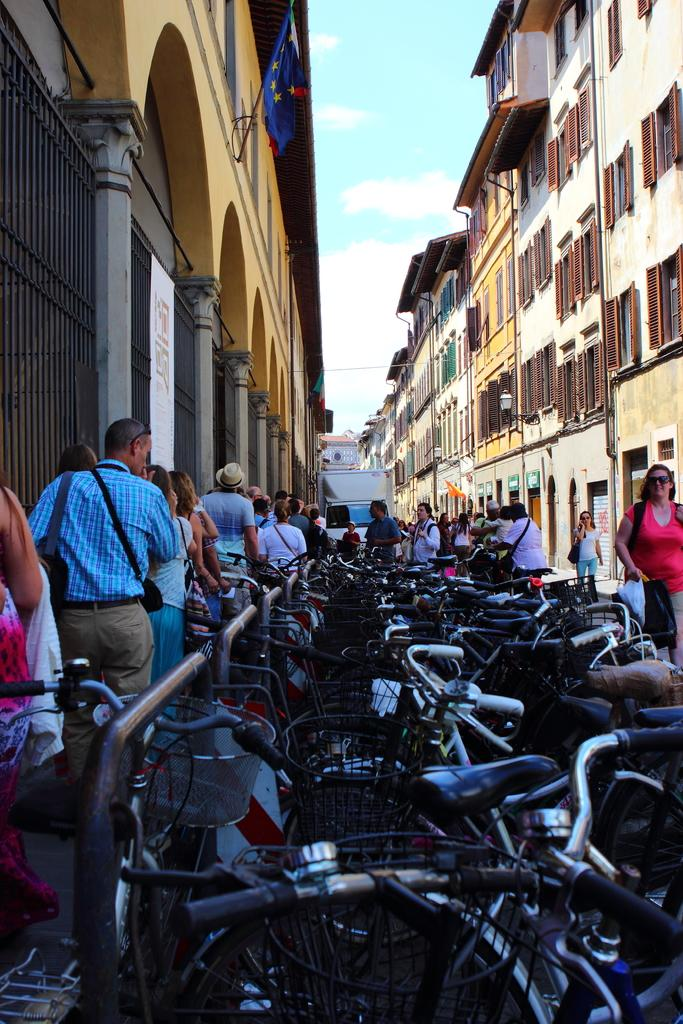What types of structures can be seen in the image? There are buildings in the image. What else can be seen moving in the image? There are vehicles in the image. Are there any living beings present in the image? Yes, there are people in the image. What architectural features can be observed on the buildings? There are windows and pillars in the image. What is attached to the buildings? There are flags in the image. What is visible in the background of the image? The sky is visible in the background of the image, and clouds are present in the sky. Where is the unit of measurement for the kettle located in the image? There is no kettle present in the image, and therefore no unit of measurement for it. What type of paste is being used to decorate the buildings in the image? There is no paste or decoration visible on the buildings in the image. 